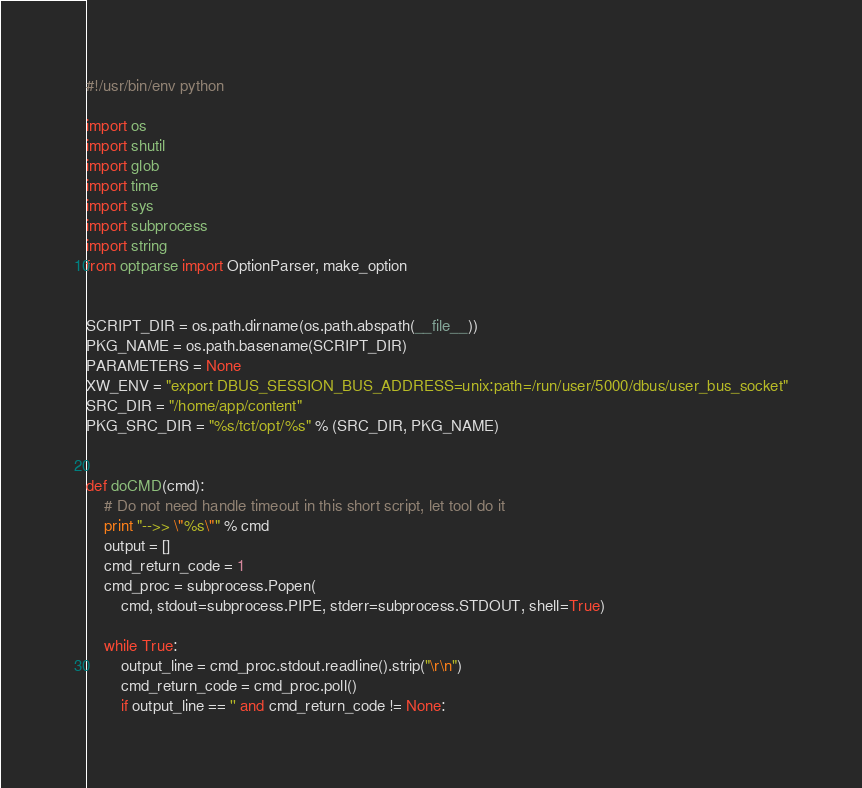Convert code to text. <code><loc_0><loc_0><loc_500><loc_500><_Python_>#!/usr/bin/env python

import os
import shutil
import glob
import time
import sys
import subprocess
import string
from optparse import OptionParser, make_option


SCRIPT_DIR = os.path.dirname(os.path.abspath(__file__))
PKG_NAME = os.path.basename(SCRIPT_DIR)
PARAMETERS = None
XW_ENV = "export DBUS_SESSION_BUS_ADDRESS=unix:path=/run/user/5000/dbus/user_bus_socket"
SRC_DIR = "/home/app/content"
PKG_SRC_DIR = "%s/tct/opt/%s" % (SRC_DIR, PKG_NAME)


def doCMD(cmd):
    # Do not need handle timeout in this short script, let tool do it
    print "-->> \"%s\"" % cmd
    output = []
    cmd_return_code = 1
    cmd_proc = subprocess.Popen(
        cmd, stdout=subprocess.PIPE, stderr=subprocess.STDOUT, shell=True)

    while True:
        output_line = cmd_proc.stdout.readline().strip("\r\n")
        cmd_return_code = cmd_proc.poll()
        if output_line == '' and cmd_return_code != None:</code> 